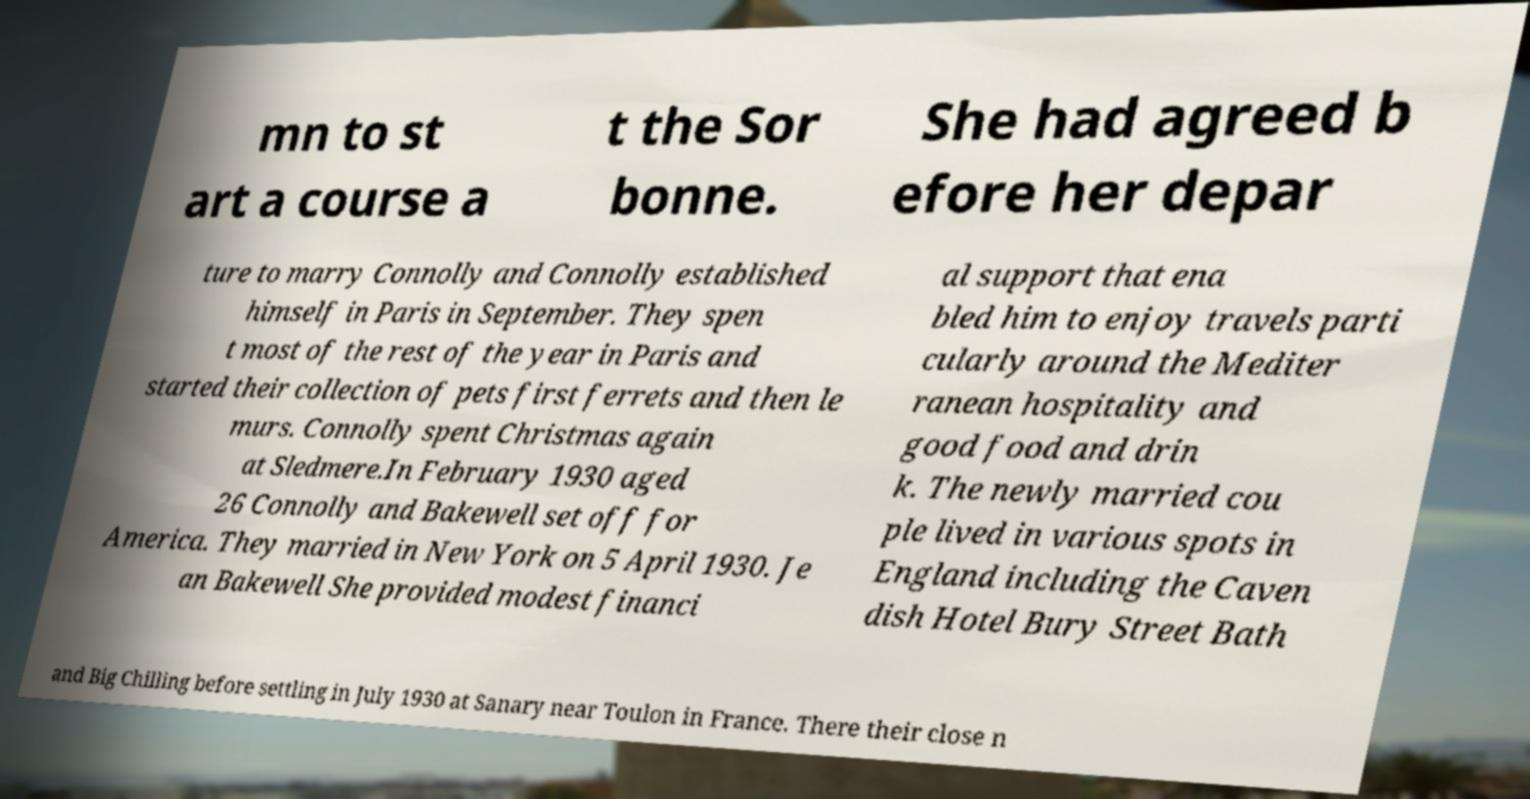Can you read and provide the text displayed in the image?This photo seems to have some interesting text. Can you extract and type it out for me? mn to st art a course a t the Sor bonne. She had agreed b efore her depar ture to marry Connolly and Connolly established himself in Paris in September. They spen t most of the rest of the year in Paris and started their collection of pets first ferrets and then le murs. Connolly spent Christmas again at Sledmere.In February 1930 aged 26 Connolly and Bakewell set off for America. They married in New York on 5 April 1930. Je an Bakewell She provided modest financi al support that ena bled him to enjoy travels parti cularly around the Mediter ranean hospitality and good food and drin k. The newly married cou ple lived in various spots in England including the Caven dish Hotel Bury Street Bath and Big Chilling before settling in July 1930 at Sanary near Toulon in France. There their close n 